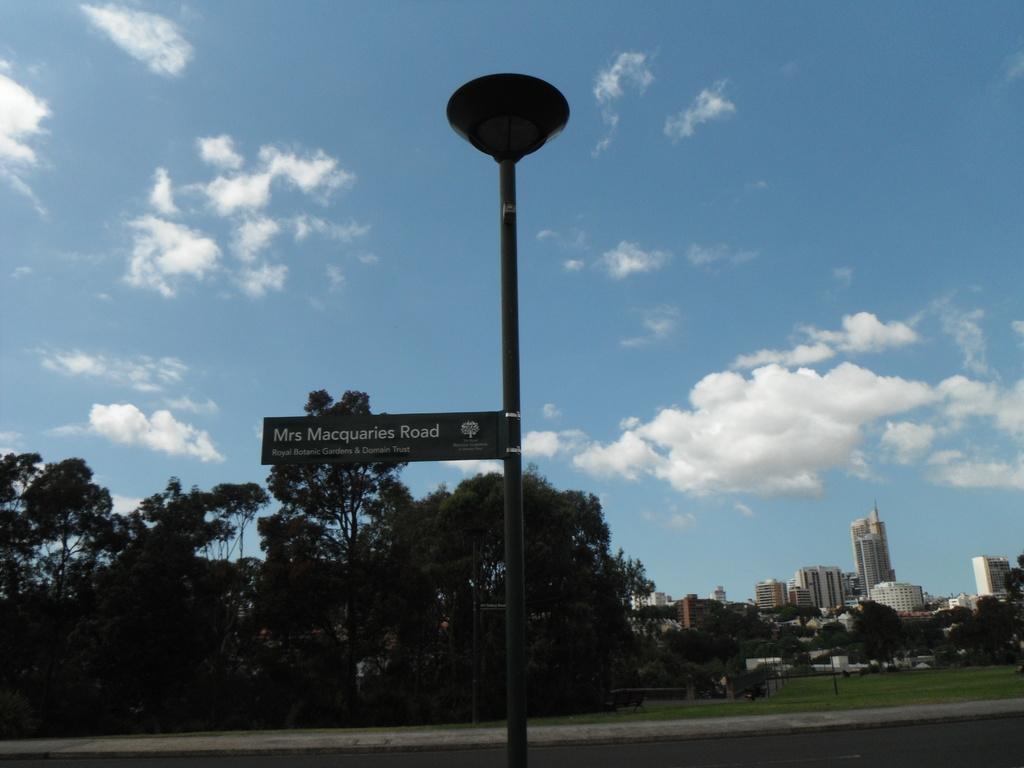Please provide a concise description of this image. In this image, I can see a name board attached to a light pole. There are trees and buildings. In the background, I can see the sky. 